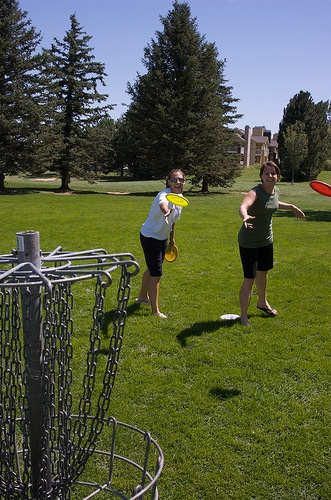Describe the objects in this image and their specific colors. I can see people in black, darkgreen, and gray tones, people in black and gray tones, frisbee in black, brown, maroon, and lightpink tones, frisbee in black, gold, olive, and tan tones, and frisbee in black and olive tones in this image. 